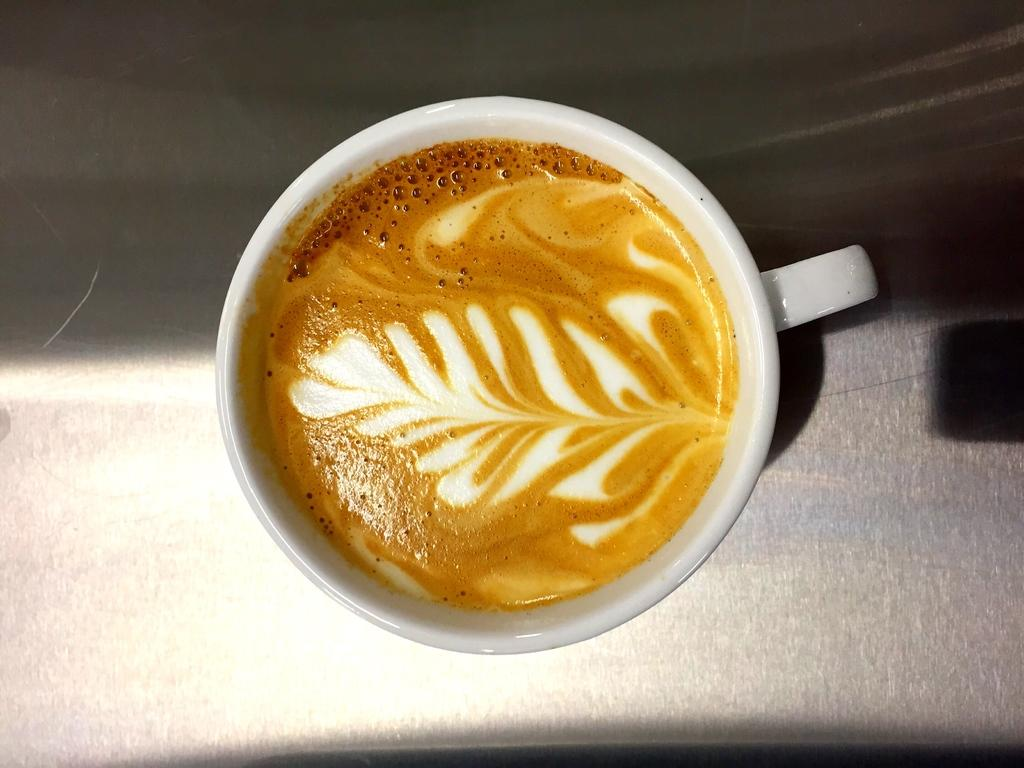What is in the cup that is visible in the image? There is a cup of coffee in the image. Where is the cup of coffee located? The cup of coffee is placed on a surface. What type of ornament is the stranger holding in the hospital in the image? There is no ornament, stranger, or hospital present in the image; it only features a cup of coffee placed on a surface. 